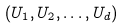Convert formula to latex. <formula><loc_0><loc_0><loc_500><loc_500>( U _ { 1 } , U _ { 2 } , \dots , U _ { d } )</formula> 